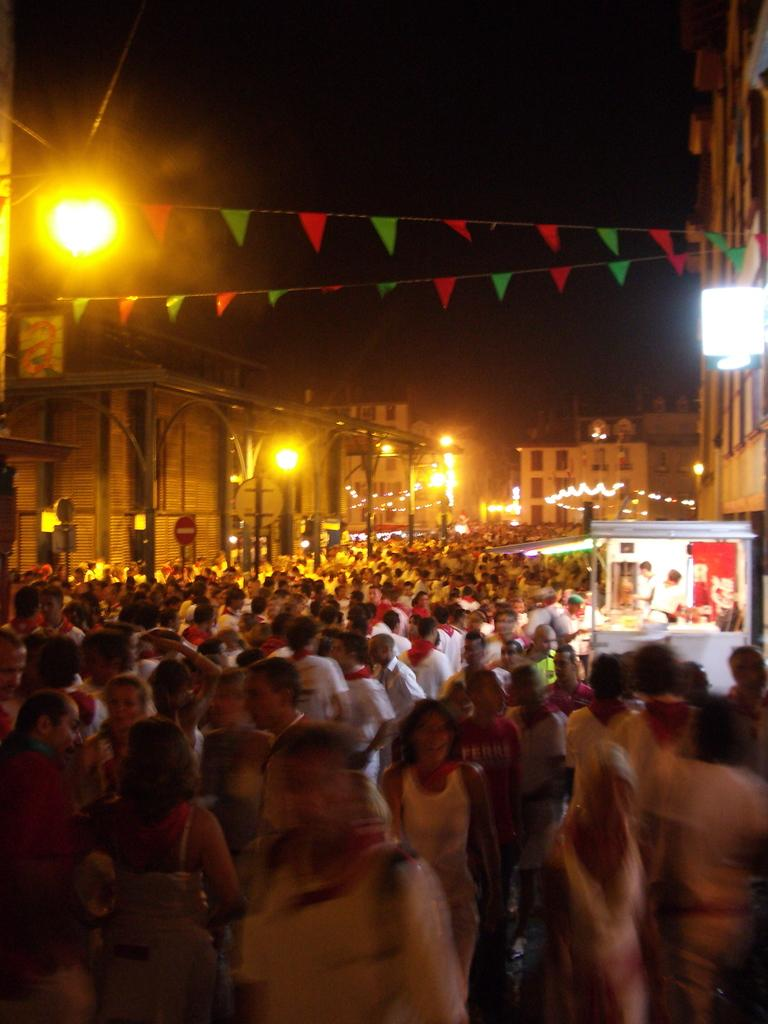What is the main feature of the image? There is a huge crowd in the image. What can be seen on the right side of the image? There is a food stall on the right side of the image. What is the surrounding environment like? There are many buildings around the crowd. What type of lighting is present in the image? Street lights are present in the image. What type of volleyball match is taking place in the image? There is no volleyball match present in the image; it features a huge crowd and a food stall. What do people in the crowd believe about the ongoing battle in the image? There is no battle present in the image, so it is not possible to determine what people in the crowd might believe about it. 